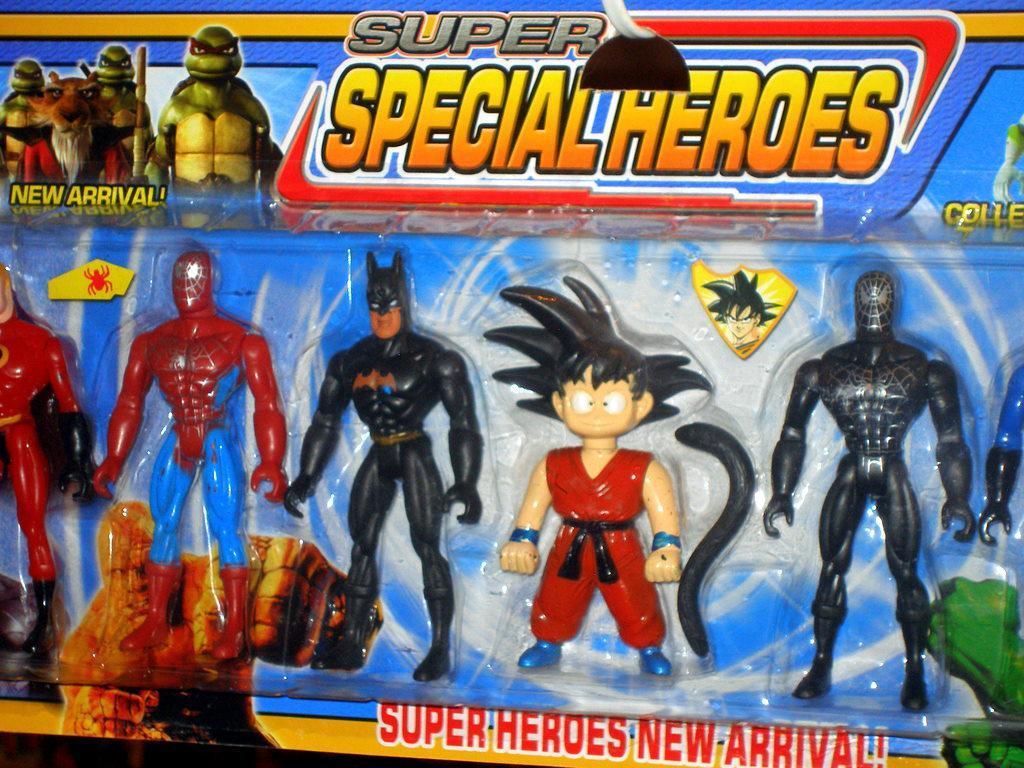Provide a one-sentence caption for the provided image. collection of Super Special Heroes for kids to play with. 